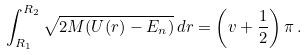<formula> <loc_0><loc_0><loc_500><loc_500>\int _ { R _ { 1 } } ^ { R _ { 2 } } \sqrt { 2 M ( U ( r ) - E _ { n } ) } \, d r = \left ( v + \frac { 1 } { 2 } \right ) \pi \, .</formula> 